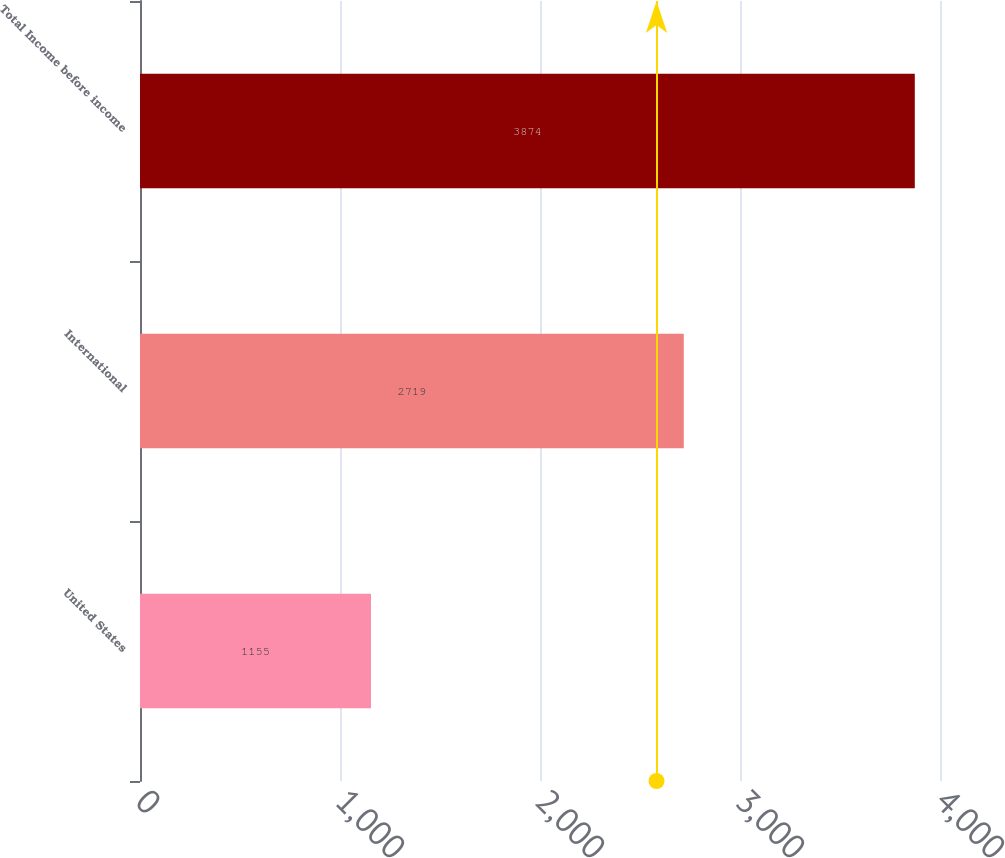Convert chart to OTSL. <chart><loc_0><loc_0><loc_500><loc_500><bar_chart><fcel>United States<fcel>International<fcel>Total Income before income<nl><fcel>1155<fcel>2719<fcel>3874<nl></chart> 